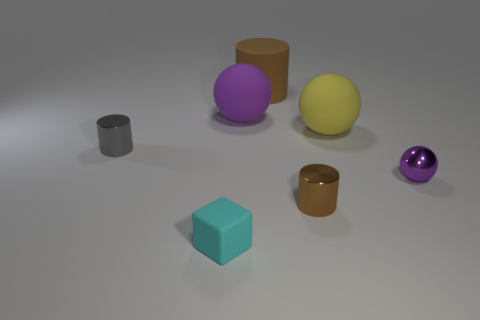How big is the ball behind the yellow sphere?
Ensure brevity in your answer.  Large. What shape is the small thing that is the same color as the large rubber cylinder?
Give a very brief answer. Cylinder. Is the material of the tiny ball the same as the small cylinder on the right side of the small cyan thing?
Keep it short and to the point. Yes. There is a tiny metal cylinder left of the purple object that is behind the small gray metallic cylinder; how many large balls are on the right side of it?
Offer a terse response. 2. What number of purple things are big balls or shiny objects?
Provide a short and direct response. 2. The tiny metal object left of the cube has what shape?
Offer a very short reply. Cylinder. The block that is the same size as the brown shiny thing is what color?
Give a very brief answer. Cyan. Do the large brown rubber object and the shiny thing that is behind the tiny purple sphere have the same shape?
Ensure brevity in your answer.  Yes. What is the material of the thing that is behind the purple sphere to the left of the cylinder that is behind the gray shiny cylinder?
Provide a succinct answer. Rubber. What number of tiny things are rubber cylinders or cyan blocks?
Provide a succinct answer. 1. 